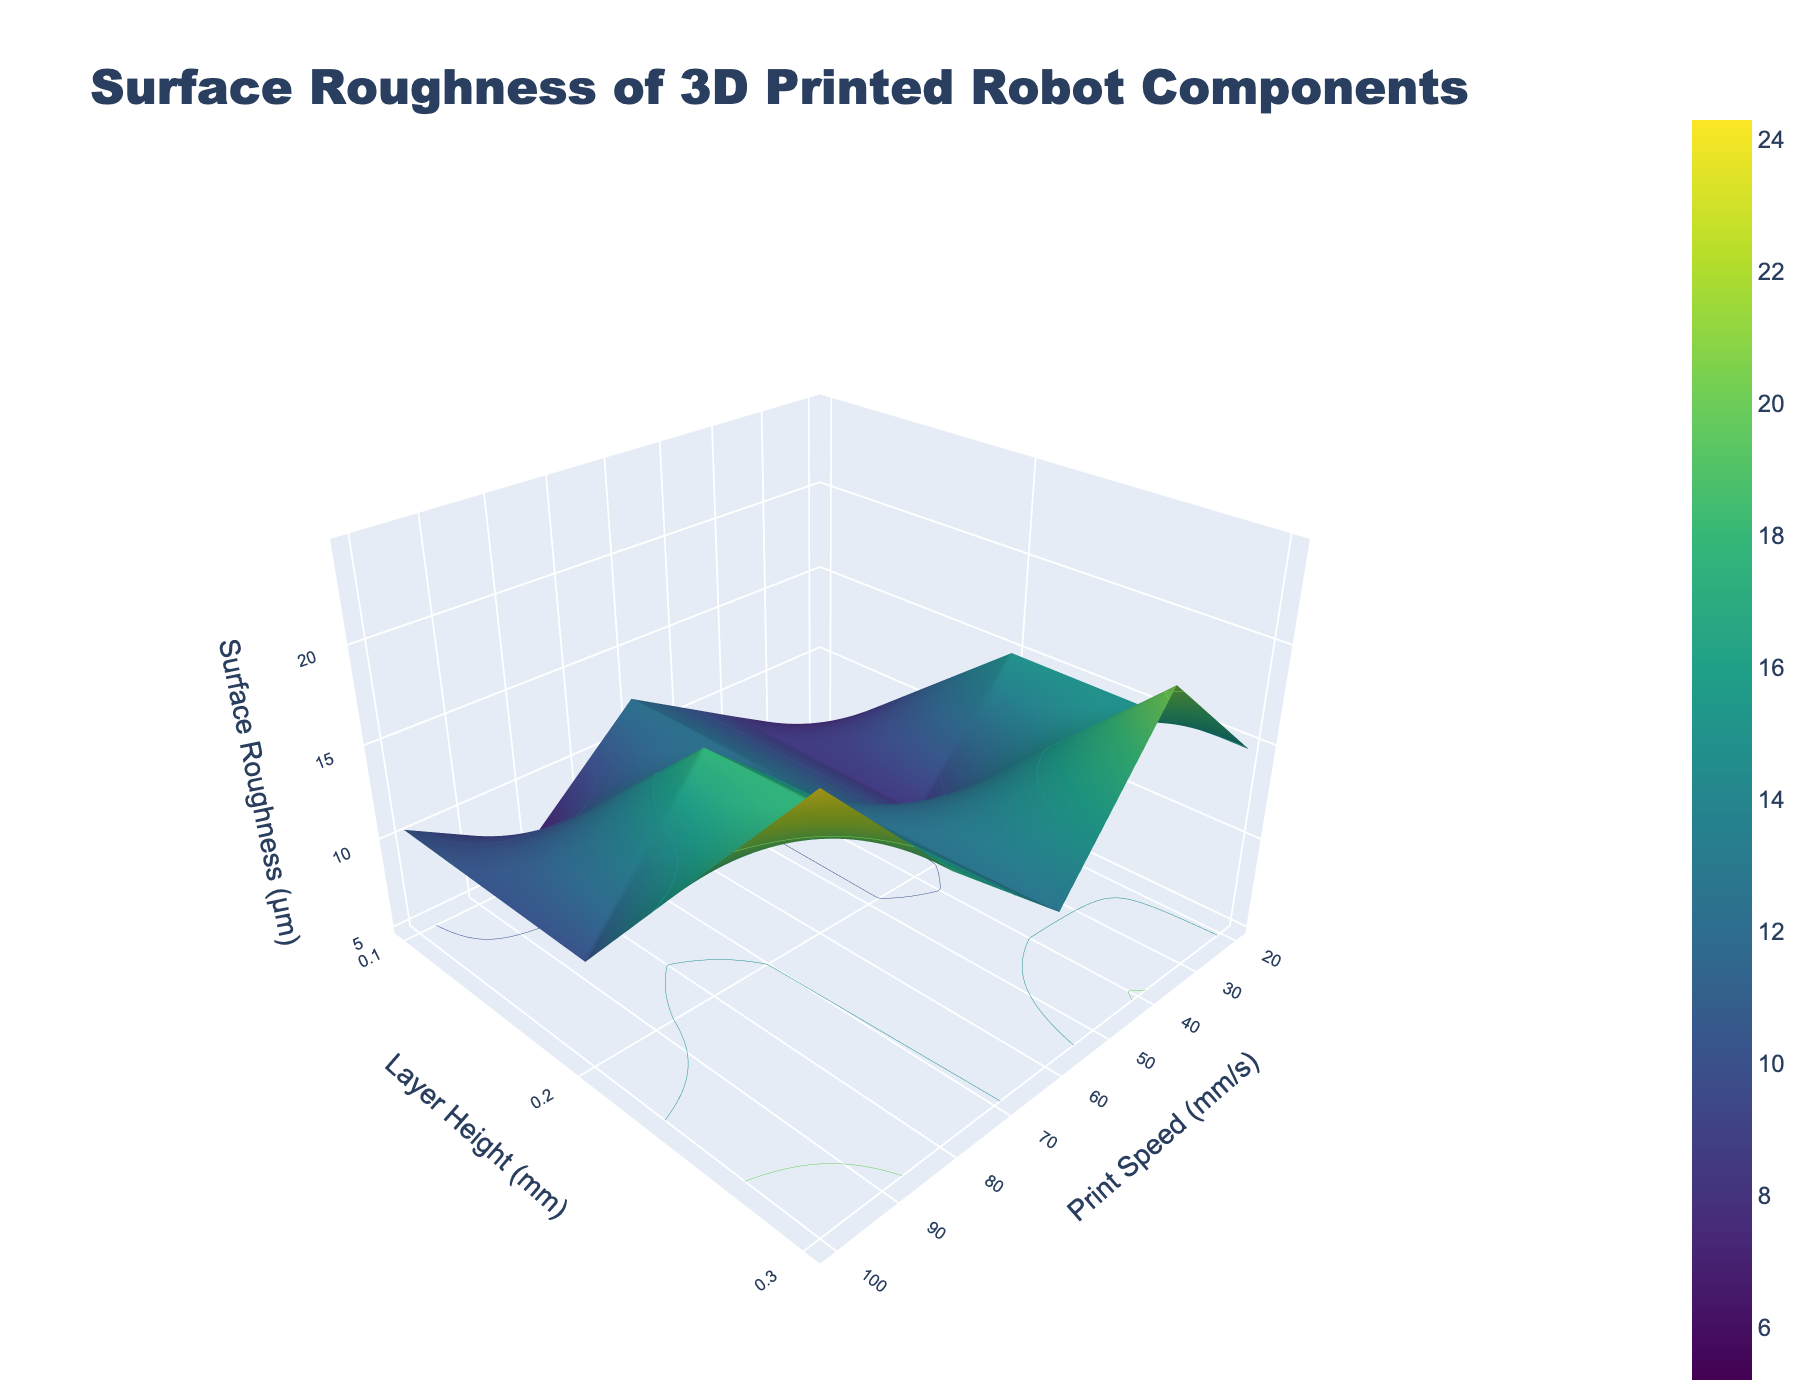What is the title of the plot? The title is shown at the top of the plot, indicating the focus of the visual representation. It reads 'Surface Roughness of 3D Printed Robot Components'.
Answer: Surface Roughness of 3D Printed Robot Components What is the axis that represents Print Speed? The axis titles are labeled on the plot. The 'Print Speed (mm/s)' is represented along the x-axis.
Answer: x-axis Which color represents the lowest surface roughness? The color scale on the plot shows that the lowest surface roughness is represented by the darkest color, typically dark blue in a Viridis color scheme.
Answer: Dark Blue For a layer height of 0.2 mm, what happens to surface roughness as print speed increases? As print speed increases, referring to 20mm/s, 40mm/s, 60mm/s, 80mm/s, and 100mm/s along the x-axis, the surface roughness increases, which can be observed as moving upwards along the z-axis.
Answer: Increases What is the surface roughness when the print speed is 60 mm/s and the layer height is 0.3 mm? By identifying the point corresponding to 60 mm/s on the x-axis and 0.3 mm on the y-axis, the z value indicates surface roughness. It reads approximately 17.6 µm.
Answer: 17.6 µm Does increasing layer height have a larger impact on surface roughness at higher print speeds? By comparing the slopes or elevation changes in the z-direction for different layer heights across the plot, steeper increases in surface roughness at higher print speeds suggest a larger impact.
Answer: Yes Which combination of print speed and layer height results in the highest surface roughness? The highest surface roughness is observed at the peak along the z-axis, corresponding to the highest x and y-axis values, being 100 mm/s print speed and 0.3 mm layer height.
Answer: 100 mm/s and 0.3 mm At print speed of 40 mm/s, how much does the surface roughness increase when layer height changes from 0.1 mm to 0.3 mm? Checking surface roughness at 40 mm/s for layer heights of 0.1 mm (6.8 µm) and 0.3 mm (14.9 µm), the increase is 14.9 - 6.8.
Answer: 8.1 µm What is the average surface roughness for a print speed of 80 mm/s across all layer heights? Surface roughness values at 80 mm/s are 10.2, 14.8, and 20.5 µm. The average is calculated as (10.2 + 14.8 + 20.5) / 3.
Answer: 15.17 µm In what direction should you adjust the print speed if you want to achieve lower surface roughness for a given layer height? Observing the plot, lower surface roughness corresponds to lower print speeds along the x-axis, so print speed should be reduced.
Answer: Reduce print speed 